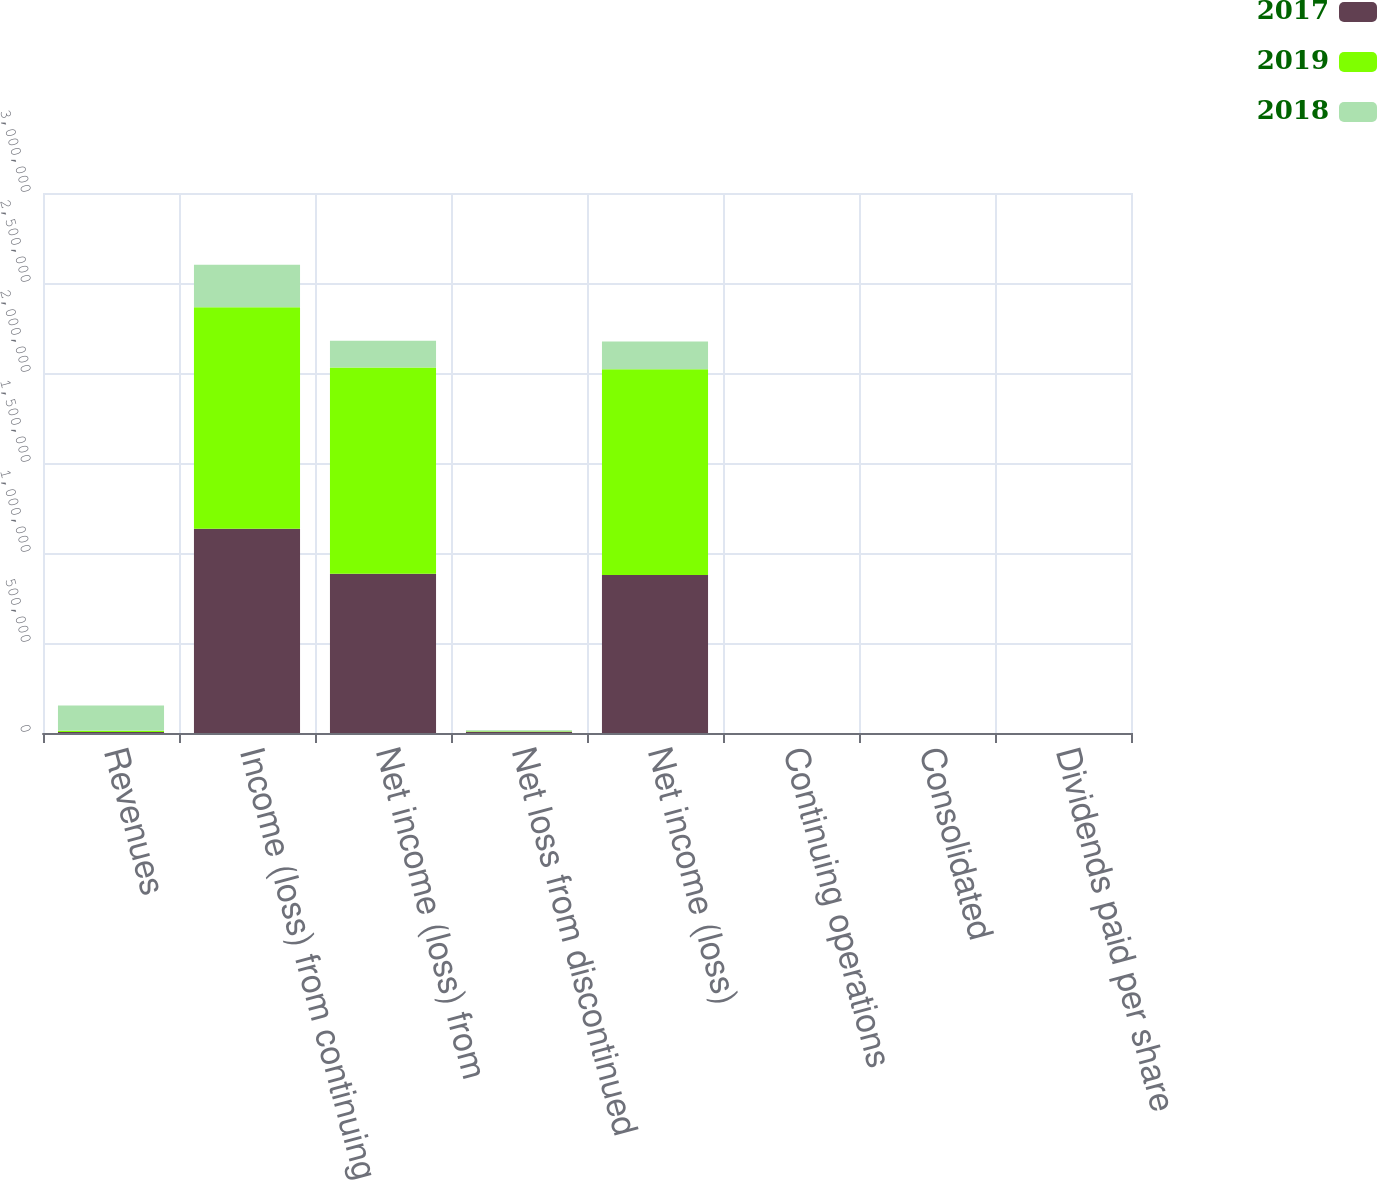Convert chart to OTSL. <chart><loc_0><loc_0><loc_500><loc_500><stacked_bar_chart><ecel><fcel>Revenues<fcel>Income (loss) from continuing<fcel>Net income (loss) from<fcel>Net loss from discontinued<fcel>Net income (loss)<fcel>Continuing operations<fcel>Consolidated<fcel>Dividends paid per share<nl><fcel>2017<fcel>6057<fcel>1.13458e+06<fcel>884769<fcel>6860<fcel>877909<fcel>4.36<fcel>4.32<fcel>0.25<nl><fcel>2019<fcel>6057<fcel>1.23102e+06<fcel>1.14596e+06<fcel>3037<fcel>1.14293e+06<fcel>5.47<fcel>5.45<fcel>0.24<nl><fcel>2018<fcel>140854<fcel>236265<fcel>148312<fcel>5254<fcel>153566<fcel>0.71<fcel>0.74<fcel>0.24<nl></chart> 